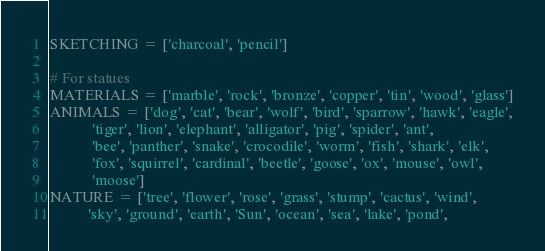<code> <loc_0><loc_0><loc_500><loc_500><_Python_>SKETCHING = ['charcoal', 'pencil']

# For statues
MATERIALS = ['marble', 'rock', 'bronze', 'copper', 'tin', 'wood', 'glass']
ANIMALS = ['dog', 'cat', 'bear', 'wolf', 'bird', 'sparrow', 'hawk', 'eagle',
           'tiger', 'lion', 'elephant', 'alligator', 'pig', 'spider', 'ant',
           'bee', 'panther', 'snake', 'crocodile', 'worm', 'fish', 'shark', 'elk',
           'fox', 'squirrel', 'cardinal', 'beetle', 'goose', 'ox', 'mouse', 'owl',
           'moose']
NATURE = ['tree', 'flower', 'rose', 'grass', 'stump', 'cactus', 'wind',
          'sky', 'ground', 'earth', 'Sun', 'ocean', 'sea', 'lake', 'pond',</code> 